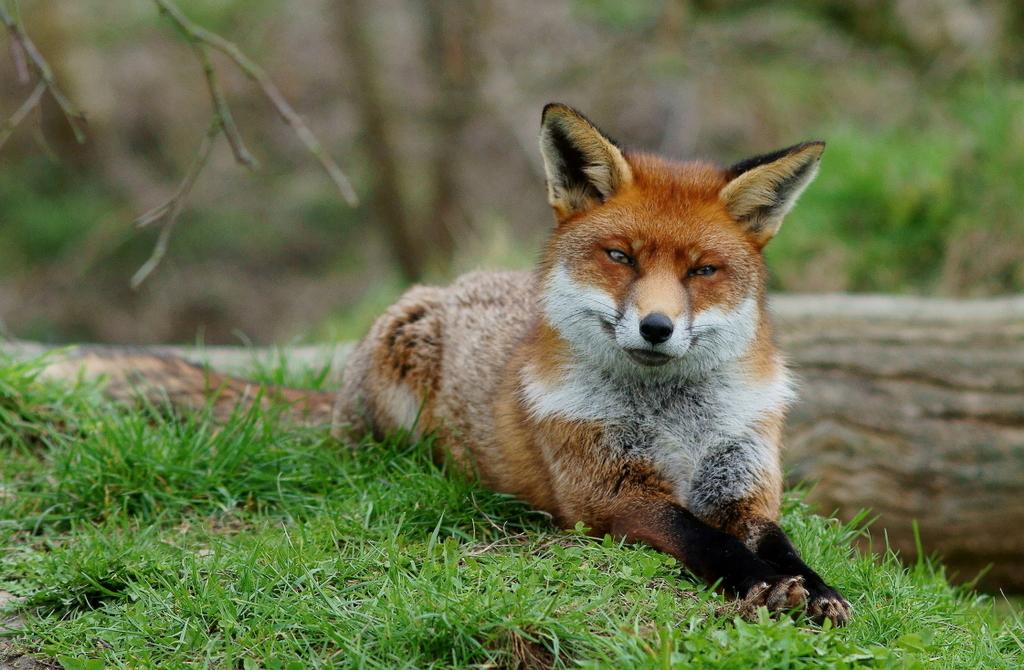What animal is present on the ground in the image? There is a jackal on the ground in the image. What type of vegetation can be seen on the ground in the image? There is grass on the ground in the image. What other object is present on the ground in the image? There is a wood log on the ground in the image. Can you describe the background of the image? The background of the image is blurry. How many books are being held by the women in the image? There are no women or books present in the image; it features a jackal, grass, and a wood log on the ground. 